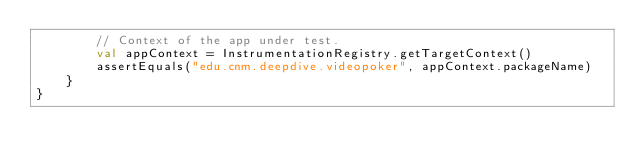<code> <loc_0><loc_0><loc_500><loc_500><_Kotlin_>        // Context of the app under test.
        val appContext = InstrumentationRegistry.getTargetContext()
        assertEquals("edu.cnm.deepdive.videopoker", appContext.packageName)
    }
}
</code> 